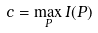<formula> <loc_0><loc_0><loc_500><loc_500>c = \max _ { P } I ( P )</formula> 